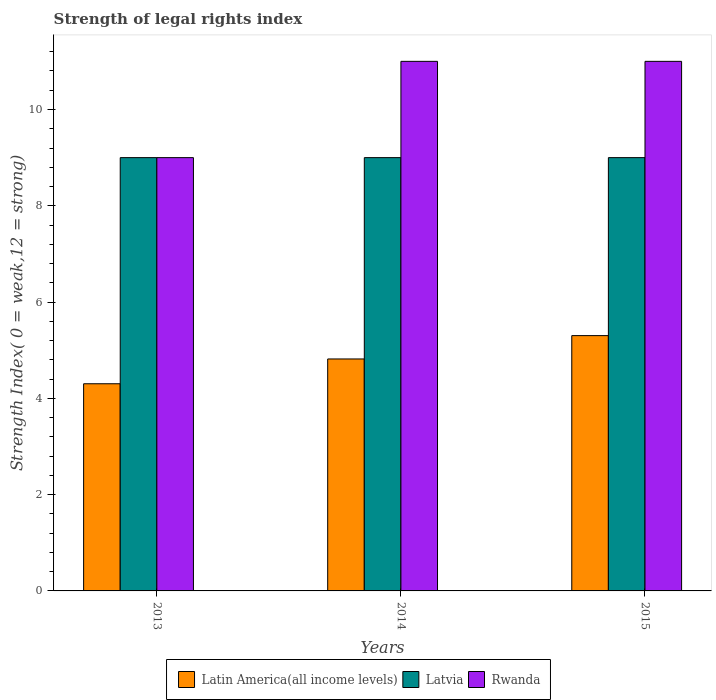How many different coloured bars are there?
Keep it short and to the point. 3. Are the number of bars on each tick of the X-axis equal?
Ensure brevity in your answer.  Yes. How many bars are there on the 1st tick from the left?
Offer a terse response. 3. How many bars are there on the 3rd tick from the right?
Provide a succinct answer. 3. What is the label of the 3rd group of bars from the left?
Give a very brief answer. 2015. What is the strength index in Latin America(all income levels) in 2014?
Your answer should be compact. 4.82. Across all years, what is the maximum strength index in Latvia?
Ensure brevity in your answer.  9. Across all years, what is the minimum strength index in Rwanda?
Your answer should be compact. 9. In which year was the strength index in Rwanda maximum?
Offer a terse response. 2014. What is the total strength index in Rwanda in the graph?
Make the answer very short. 31. What is the difference between the strength index in Latvia in 2013 and that in 2015?
Your response must be concise. 0. What is the difference between the strength index in Latvia in 2015 and the strength index in Latin America(all income levels) in 2013?
Keep it short and to the point. 4.7. What is the average strength index in Latvia per year?
Your answer should be compact. 9. In the year 2013, what is the difference between the strength index in Rwanda and strength index in Latvia?
Provide a short and direct response. 0. What is the ratio of the strength index in Rwanda in 2013 to that in 2015?
Offer a terse response. 0.82. What is the difference between the highest and the lowest strength index in Rwanda?
Make the answer very short. 2. What does the 3rd bar from the left in 2013 represents?
Ensure brevity in your answer.  Rwanda. What does the 1st bar from the right in 2013 represents?
Offer a terse response. Rwanda. Is it the case that in every year, the sum of the strength index in Latvia and strength index in Rwanda is greater than the strength index in Latin America(all income levels)?
Keep it short and to the point. Yes. How many years are there in the graph?
Provide a succinct answer. 3. Where does the legend appear in the graph?
Make the answer very short. Bottom center. What is the title of the graph?
Offer a very short reply. Strength of legal rights index. Does "Bulgaria" appear as one of the legend labels in the graph?
Provide a short and direct response. No. What is the label or title of the Y-axis?
Ensure brevity in your answer.  Strength Index( 0 = weak,12 = strong). What is the Strength Index( 0 = weak,12 = strong) of Latin America(all income levels) in 2013?
Ensure brevity in your answer.  4.3. What is the Strength Index( 0 = weak,12 = strong) of Rwanda in 2013?
Give a very brief answer. 9. What is the Strength Index( 0 = weak,12 = strong) of Latin America(all income levels) in 2014?
Ensure brevity in your answer.  4.82. What is the Strength Index( 0 = weak,12 = strong) in Latin America(all income levels) in 2015?
Ensure brevity in your answer.  5.3. What is the Strength Index( 0 = weak,12 = strong) in Rwanda in 2015?
Keep it short and to the point. 11. Across all years, what is the maximum Strength Index( 0 = weak,12 = strong) in Latin America(all income levels)?
Your answer should be very brief. 5.3. Across all years, what is the maximum Strength Index( 0 = weak,12 = strong) in Rwanda?
Your response must be concise. 11. Across all years, what is the minimum Strength Index( 0 = weak,12 = strong) in Latin America(all income levels)?
Your response must be concise. 4.3. Across all years, what is the minimum Strength Index( 0 = weak,12 = strong) of Rwanda?
Your answer should be compact. 9. What is the total Strength Index( 0 = weak,12 = strong) in Latin America(all income levels) in the graph?
Offer a very short reply. 14.42. What is the total Strength Index( 0 = weak,12 = strong) in Latvia in the graph?
Provide a succinct answer. 27. What is the total Strength Index( 0 = weak,12 = strong) of Rwanda in the graph?
Offer a terse response. 31. What is the difference between the Strength Index( 0 = weak,12 = strong) in Latin America(all income levels) in 2013 and that in 2014?
Your answer should be compact. -0.52. What is the difference between the Strength Index( 0 = weak,12 = strong) in Latin America(all income levels) in 2013 and that in 2015?
Make the answer very short. -1. What is the difference between the Strength Index( 0 = weak,12 = strong) of Rwanda in 2013 and that in 2015?
Your answer should be very brief. -2. What is the difference between the Strength Index( 0 = weak,12 = strong) of Latin America(all income levels) in 2014 and that in 2015?
Provide a short and direct response. -0.48. What is the difference between the Strength Index( 0 = weak,12 = strong) of Latvia in 2014 and that in 2015?
Provide a succinct answer. 0. What is the difference between the Strength Index( 0 = weak,12 = strong) in Latin America(all income levels) in 2013 and the Strength Index( 0 = weak,12 = strong) in Latvia in 2014?
Provide a short and direct response. -4.7. What is the difference between the Strength Index( 0 = weak,12 = strong) of Latin America(all income levels) in 2013 and the Strength Index( 0 = weak,12 = strong) of Rwanda in 2014?
Offer a very short reply. -6.7. What is the difference between the Strength Index( 0 = weak,12 = strong) in Latin America(all income levels) in 2013 and the Strength Index( 0 = weak,12 = strong) in Latvia in 2015?
Ensure brevity in your answer.  -4.7. What is the difference between the Strength Index( 0 = weak,12 = strong) in Latin America(all income levels) in 2013 and the Strength Index( 0 = weak,12 = strong) in Rwanda in 2015?
Offer a terse response. -6.7. What is the difference between the Strength Index( 0 = weak,12 = strong) of Latvia in 2013 and the Strength Index( 0 = weak,12 = strong) of Rwanda in 2015?
Ensure brevity in your answer.  -2. What is the difference between the Strength Index( 0 = weak,12 = strong) in Latin America(all income levels) in 2014 and the Strength Index( 0 = weak,12 = strong) in Latvia in 2015?
Offer a terse response. -4.18. What is the difference between the Strength Index( 0 = weak,12 = strong) in Latin America(all income levels) in 2014 and the Strength Index( 0 = weak,12 = strong) in Rwanda in 2015?
Offer a terse response. -6.18. What is the average Strength Index( 0 = weak,12 = strong) in Latin America(all income levels) per year?
Give a very brief answer. 4.81. What is the average Strength Index( 0 = weak,12 = strong) of Rwanda per year?
Provide a succinct answer. 10.33. In the year 2013, what is the difference between the Strength Index( 0 = weak,12 = strong) of Latin America(all income levels) and Strength Index( 0 = weak,12 = strong) of Latvia?
Provide a short and direct response. -4.7. In the year 2013, what is the difference between the Strength Index( 0 = weak,12 = strong) in Latin America(all income levels) and Strength Index( 0 = weak,12 = strong) in Rwanda?
Provide a succinct answer. -4.7. In the year 2013, what is the difference between the Strength Index( 0 = weak,12 = strong) of Latvia and Strength Index( 0 = weak,12 = strong) of Rwanda?
Give a very brief answer. 0. In the year 2014, what is the difference between the Strength Index( 0 = weak,12 = strong) of Latin America(all income levels) and Strength Index( 0 = weak,12 = strong) of Latvia?
Keep it short and to the point. -4.18. In the year 2014, what is the difference between the Strength Index( 0 = weak,12 = strong) of Latin America(all income levels) and Strength Index( 0 = weak,12 = strong) of Rwanda?
Provide a succinct answer. -6.18. In the year 2014, what is the difference between the Strength Index( 0 = weak,12 = strong) in Latvia and Strength Index( 0 = weak,12 = strong) in Rwanda?
Provide a short and direct response. -2. In the year 2015, what is the difference between the Strength Index( 0 = weak,12 = strong) in Latin America(all income levels) and Strength Index( 0 = weak,12 = strong) in Latvia?
Your answer should be very brief. -3.7. In the year 2015, what is the difference between the Strength Index( 0 = weak,12 = strong) of Latin America(all income levels) and Strength Index( 0 = weak,12 = strong) of Rwanda?
Give a very brief answer. -5.7. In the year 2015, what is the difference between the Strength Index( 0 = weak,12 = strong) in Latvia and Strength Index( 0 = weak,12 = strong) in Rwanda?
Provide a short and direct response. -2. What is the ratio of the Strength Index( 0 = weak,12 = strong) of Latin America(all income levels) in 2013 to that in 2014?
Make the answer very short. 0.89. What is the ratio of the Strength Index( 0 = weak,12 = strong) in Latvia in 2013 to that in 2014?
Give a very brief answer. 1. What is the ratio of the Strength Index( 0 = weak,12 = strong) of Rwanda in 2013 to that in 2014?
Give a very brief answer. 0.82. What is the ratio of the Strength Index( 0 = weak,12 = strong) of Latin America(all income levels) in 2013 to that in 2015?
Your response must be concise. 0.81. What is the ratio of the Strength Index( 0 = weak,12 = strong) in Rwanda in 2013 to that in 2015?
Provide a succinct answer. 0.82. What is the ratio of the Strength Index( 0 = weak,12 = strong) of Latin America(all income levels) in 2014 to that in 2015?
Your answer should be compact. 0.91. What is the difference between the highest and the second highest Strength Index( 0 = weak,12 = strong) of Latin America(all income levels)?
Provide a short and direct response. 0.48. What is the difference between the highest and the second highest Strength Index( 0 = weak,12 = strong) of Rwanda?
Make the answer very short. 0. What is the difference between the highest and the lowest Strength Index( 0 = weak,12 = strong) in Latin America(all income levels)?
Provide a succinct answer. 1. 